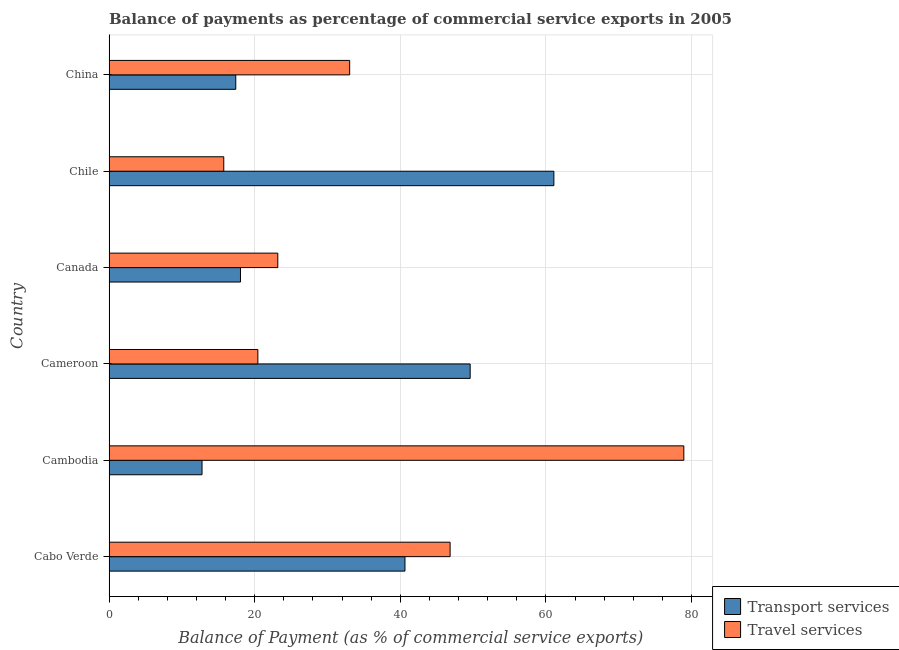How many groups of bars are there?
Ensure brevity in your answer.  6. Are the number of bars per tick equal to the number of legend labels?
Your answer should be compact. Yes. What is the label of the 4th group of bars from the top?
Keep it short and to the point. Cameroon. In how many cases, is the number of bars for a given country not equal to the number of legend labels?
Your answer should be compact. 0. What is the balance of payments of travel services in Cabo Verde?
Your answer should be compact. 46.84. Across all countries, what is the maximum balance of payments of travel services?
Offer a terse response. 78.94. Across all countries, what is the minimum balance of payments of travel services?
Provide a short and direct response. 15.75. In which country was the balance of payments of travel services maximum?
Make the answer very short. Cambodia. What is the total balance of payments of travel services in the graph?
Provide a short and direct response. 218.18. What is the difference between the balance of payments of travel services in Cabo Verde and that in Chile?
Your answer should be compact. 31.09. What is the difference between the balance of payments of travel services in Cambodia and the balance of payments of transport services in Cabo Verde?
Give a very brief answer. 38.3. What is the average balance of payments of transport services per country?
Give a very brief answer. 33.26. What is the difference between the balance of payments of travel services and balance of payments of transport services in Chile?
Offer a terse response. -45.34. In how many countries, is the balance of payments of travel services greater than 36 %?
Keep it short and to the point. 2. What is the ratio of the balance of payments of transport services in Cabo Verde to that in Cameroon?
Provide a short and direct response. 0.82. What is the difference between the highest and the second highest balance of payments of travel services?
Offer a terse response. 32.1. What is the difference between the highest and the lowest balance of payments of travel services?
Your answer should be compact. 63.19. In how many countries, is the balance of payments of travel services greater than the average balance of payments of travel services taken over all countries?
Provide a succinct answer. 2. What does the 1st bar from the top in Cabo Verde represents?
Offer a very short reply. Travel services. What does the 2nd bar from the bottom in China represents?
Provide a short and direct response. Travel services. How many bars are there?
Keep it short and to the point. 12. Are all the bars in the graph horizontal?
Give a very brief answer. Yes. Are the values on the major ticks of X-axis written in scientific E-notation?
Your response must be concise. No. Does the graph contain any zero values?
Ensure brevity in your answer.  No. Where does the legend appear in the graph?
Your answer should be very brief. Bottom right. How many legend labels are there?
Your response must be concise. 2. How are the legend labels stacked?
Provide a short and direct response. Vertical. What is the title of the graph?
Offer a terse response. Balance of payments as percentage of commercial service exports in 2005. Does "Not attending school" appear as one of the legend labels in the graph?
Your response must be concise. No. What is the label or title of the X-axis?
Keep it short and to the point. Balance of Payment (as % of commercial service exports). What is the label or title of the Y-axis?
Offer a very short reply. Country. What is the Balance of Payment (as % of commercial service exports) of Transport services in Cabo Verde?
Ensure brevity in your answer.  40.64. What is the Balance of Payment (as % of commercial service exports) in Travel services in Cabo Verde?
Your response must be concise. 46.84. What is the Balance of Payment (as % of commercial service exports) of Transport services in Cambodia?
Offer a very short reply. 12.77. What is the Balance of Payment (as % of commercial service exports) of Travel services in Cambodia?
Keep it short and to the point. 78.94. What is the Balance of Payment (as % of commercial service exports) of Transport services in Cameroon?
Give a very brief answer. 49.59. What is the Balance of Payment (as % of commercial service exports) of Travel services in Cameroon?
Ensure brevity in your answer.  20.43. What is the Balance of Payment (as % of commercial service exports) of Transport services in Canada?
Offer a very short reply. 18.05. What is the Balance of Payment (as % of commercial service exports) in Travel services in Canada?
Provide a succinct answer. 23.17. What is the Balance of Payment (as % of commercial service exports) of Transport services in Chile?
Keep it short and to the point. 61.09. What is the Balance of Payment (as % of commercial service exports) of Travel services in Chile?
Offer a terse response. 15.75. What is the Balance of Payment (as % of commercial service exports) in Transport services in China?
Offer a terse response. 17.4. What is the Balance of Payment (as % of commercial service exports) of Travel services in China?
Your response must be concise. 33.04. Across all countries, what is the maximum Balance of Payment (as % of commercial service exports) of Transport services?
Give a very brief answer. 61.09. Across all countries, what is the maximum Balance of Payment (as % of commercial service exports) of Travel services?
Give a very brief answer. 78.94. Across all countries, what is the minimum Balance of Payment (as % of commercial service exports) of Transport services?
Provide a succinct answer. 12.77. Across all countries, what is the minimum Balance of Payment (as % of commercial service exports) of Travel services?
Give a very brief answer. 15.75. What is the total Balance of Payment (as % of commercial service exports) of Transport services in the graph?
Provide a short and direct response. 199.54. What is the total Balance of Payment (as % of commercial service exports) in Travel services in the graph?
Offer a terse response. 218.18. What is the difference between the Balance of Payment (as % of commercial service exports) in Transport services in Cabo Verde and that in Cambodia?
Your answer should be compact. 27.87. What is the difference between the Balance of Payment (as % of commercial service exports) of Travel services in Cabo Verde and that in Cambodia?
Give a very brief answer. -32.1. What is the difference between the Balance of Payment (as % of commercial service exports) in Transport services in Cabo Verde and that in Cameroon?
Ensure brevity in your answer.  -8.95. What is the difference between the Balance of Payment (as % of commercial service exports) of Travel services in Cabo Verde and that in Cameroon?
Offer a very short reply. 26.4. What is the difference between the Balance of Payment (as % of commercial service exports) in Transport services in Cabo Verde and that in Canada?
Ensure brevity in your answer.  22.59. What is the difference between the Balance of Payment (as % of commercial service exports) of Travel services in Cabo Verde and that in Canada?
Keep it short and to the point. 23.66. What is the difference between the Balance of Payment (as % of commercial service exports) of Transport services in Cabo Verde and that in Chile?
Keep it short and to the point. -20.45. What is the difference between the Balance of Payment (as % of commercial service exports) in Travel services in Cabo Verde and that in Chile?
Make the answer very short. 31.08. What is the difference between the Balance of Payment (as % of commercial service exports) of Transport services in Cabo Verde and that in China?
Make the answer very short. 23.24. What is the difference between the Balance of Payment (as % of commercial service exports) of Travel services in Cabo Verde and that in China?
Make the answer very short. 13.79. What is the difference between the Balance of Payment (as % of commercial service exports) of Transport services in Cambodia and that in Cameroon?
Your answer should be compact. -36.83. What is the difference between the Balance of Payment (as % of commercial service exports) in Travel services in Cambodia and that in Cameroon?
Provide a short and direct response. 58.5. What is the difference between the Balance of Payment (as % of commercial service exports) of Transport services in Cambodia and that in Canada?
Ensure brevity in your answer.  -5.28. What is the difference between the Balance of Payment (as % of commercial service exports) of Travel services in Cambodia and that in Canada?
Make the answer very short. 55.76. What is the difference between the Balance of Payment (as % of commercial service exports) in Transport services in Cambodia and that in Chile?
Provide a short and direct response. -48.32. What is the difference between the Balance of Payment (as % of commercial service exports) in Travel services in Cambodia and that in Chile?
Your response must be concise. 63.19. What is the difference between the Balance of Payment (as % of commercial service exports) of Transport services in Cambodia and that in China?
Give a very brief answer. -4.63. What is the difference between the Balance of Payment (as % of commercial service exports) in Travel services in Cambodia and that in China?
Your answer should be very brief. 45.89. What is the difference between the Balance of Payment (as % of commercial service exports) of Transport services in Cameroon and that in Canada?
Your response must be concise. 31.55. What is the difference between the Balance of Payment (as % of commercial service exports) of Travel services in Cameroon and that in Canada?
Give a very brief answer. -2.74. What is the difference between the Balance of Payment (as % of commercial service exports) in Transport services in Cameroon and that in Chile?
Give a very brief answer. -11.5. What is the difference between the Balance of Payment (as % of commercial service exports) of Travel services in Cameroon and that in Chile?
Offer a terse response. 4.68. What is the difference between the Balance of Payment (as % of commercial service exports) in Transport services in Cameroon and that in China?
Offer a terse response. 32.19. What is the difference between the Balance of Payment (as % of commercial service exports) in Travel services in Cameroon and that in China?
Ensure brevity in your answer.  -12.61. What is the difference between the Balance of Payment (as % of commercial service exports) of Transport services in Canada and that in Chile?
Your answer should be very brief. -43.04. What is the difference between the Balance of Payment (as % of commercial service exports) in Travel services in Canada and that in Chile?
Offer a very short reply. 7.42. What is the difference between the Balance of Payment (as % of commercial service exports) of Transport services in Canada and that in China?
Make the answer very short. 0.65. What is the difference between the Balance of Payment (as % of commercial service exports) of Travel services in Canada and that in China?
Provide a short and direct response. -9.87. What is the difference between the Balance of Payment (as % of commercial service exports) of Transport services in Chile and that in China?
Your response must be concise. 43.69. What is the difference between the Balance of Payment (as % of commercial service exports) of Travel services in Chile and that in China?
Your answer should be very brief. -17.29. What is the difference between the Balance of Payment (as % of commercial service exports) in Transport services in Cabo Verde and the Balance of Payment (as % of commercial service exports) in Travel services in Cambodia?
Provide a short and direct response. -38.3. What is the difference between the Balance of Payment (as % of commercial service exports) of Transport services in Cabo Verde and the Balance of Payment (as % of commercial service exports) of Travel services in Cameroon?
Keep it short and to the point. 20.21. What is the difference between the Balance of Payment (as % of commercial service exports) of Transport services in Cabo Verde and the Balance of Payment (as % of commercial service exports) of Travel services in Canada?
Make the answer very short. 17.47. What is the difference between the Balance of Payment (as % of commercial service exports) of Transport services in Cabo Verde and the Balance of Payment (as % of commercial service exports) of Travel services in Chile?
Provide a succinct answer. 24.89. What is the difference between the Balance of Payment (as % of commercial service exports) of Transport services in Cabo Verde and the Balance of Payment (as % of commercial service exports) of Travel services in China?
Your answer should be very brief. 7.59. What is the difference between the Balance of Payment (as % of commercial service exports) of Transport services in Cambodia and the Balance of Payment (as % of commercial service exports) of Travel services in Cameroon?
Offer a very short reply. -7.67. What is the difference between the Balance of Payment (as % of commercial service exports) in Transport services in Cambodia and the Balance of Payment (as % of commercial service exports) in Travel services in Canada?
Your answer should be compact. -10.41. What is the difference between the Balance of Payment (as % of commercial service exports) of Transport services in Cambodia and the Balance of Payment (as % of commercial service exports) of Travel services in Chile?
Provide a short and direct response. -2.99. What is the difference between the Balance of Payment (as % of commercial service exports) in Transport services in Cambodia and the Balance of Payment (as % of commercial service exports) in Travel services in China?
Offer a terse response. -20.28. What is the difference between the Balance of Payment (as % of commercial service exports) of Transport services in Cameroon and the Balance of Payment (as % of commercial service exports) of Travel services in Canada?
Your answer should be very brief. 26.42. What is the difference between the Balance of Payment (as % of commercial service exports) in Transport services in Cameroon and the Balance of Payment (as % of commercial service exports) in Travel services in Chile?
Make the answer very short. 33.84. What is the difference between the Balance of Payment (as % of commercial service exports) of Transport services in Cameroon and the Balance of Payment (as % of commercial service exports) of Travel services in China?
Your answer should be compact. 16.55. What is the difference between the Balance of Payment (as % of commercial service exports) in Transport services in Canada and the Balance of Payment (as % of commercial service exports) in Travel services in Chile?
Provide a short and direct response. 2.3. What is the difference between the Balance of Payment (as % of commercial service exports) of Transport services in Canada and the Balance of Payment (as % of commercial service exports) of Travel services in China?
Your answer should be compact. -15. What is the difference between the Balance of Payment (as % of commercial service exports) in Transport services in Chile and the Balance of Payment (as % of commercial service exports) in Travel services in China?
Your answer should be compact. 28.05. What is the average Balance of Payment (as % of commercial service exports) in Transport services per country?
Your answer should be very brief. 33.26. What is the average Balance of Payment (as % of commercial service exports) in Travel services per country?
Provide a succinct answer. 36.36. What is the difference between the Balance of Payment (as % of commercial service exports) of Transport services and Balance of Payment (as % of commercial service exports) of Travel services in Cabo Verde?
Provide a short and direct response. -6.2. What is the difference between the Balance of Payment (as % of commercial service exports) in Transport services and Balance of Payment (as % of commercial service exports) in Travel services in Cambodia?
Offer a terse response. -66.17. What is the difference between the Balance of Payment (as % of commercial service exports) of Transport services and Balance of Payment (as % of commercial service exports) of Travel services in Cameroon?
Provide a succinct answer. 29.16. What is the difference between the Balance of Payment (as % of commercial service exports) in Transport services and Balance of Payment (as % of commercial service exports) in Travel services in Canada?
Provide a short and direct response. -5.12. What is the difference between the Balance of Payment (as % of commercial service exports) of Transport services and Balance of Payment (as % of commercial service exports) of Travel services in Chile?
Offer a terse response. 45.34. What is the difference between the Balance of Payment (as % of commercial service exports) of Transport services and Balance of Payment (as % of commercial service exports) of Travel services in China?
Keep it short and to the point. -15.64. What is the ratio of the Balance of Payment (as % of commercial service exports) in Transport services in Cabo Verde to that in Cambodia?
Your answer should be very brief. 3.18. What is the ratio of the Balance of Payment (as % of commercial service exports) of Travel services in Cabo Verde to that in Cambodia?
Offer a terse response. 0.59. What is the ratio of the Balance of Payment (as % of commercial service exports) of Transport services in Cabo Verde to that in Cameroon?
Keep it short and to the point. 0.82. What is the ratio of the Balance of Payment (as % of commercial service exports) in Travel services in Cabo Verde to that in Cameroon?
Your response must be concise. 2.29. What is the ratio of the Balance of Payment (as % of commercial service exports) in Transport services in Cabo Verde to that in Canada?
Your answer should be compact. 2.25. What is the ratio of the Balance of Payment (as % of commercial service exports) in Travel services in Cabo Verde to that in Canada?
Provide a short and direct response. 2.02. What is the ratio of the Balance of Payment (as % of commercial service exports) of Transport services in Cabo Verde to that in Chile?
Keep it short and to the point. 0.67. What is the ratio of the Balance of Payment (as % of commercial service exports) in Travel services in Cabo Verde to that in Chile?
Offer a terse response. 2.97. What is the ratio of the Balance of Payment (as % of commercial service exports) of Transport services in Cabo Verde to that in China?
Keep it short and to the point. 2.34. What is the ratio of the Balance of Payment (as % of commercial service exports) in Travel services in Cabo Verde to that in China?
Ensure brevity in your answer.  1.42. What is the ratio of the Balance of Payment (as % of commercial service exports) of Transport services in Cambodia to that in Cameroon?
Give a very brief answer. 0.26. What is the ratio of the Balance of Payment (as % of commercial service exports) of Travel services in Cambodia to that in Cameroon?
Provide a succinct answer. 3.86. What is the ratio of the Balance of Payment (as % of commercial service exports) of Transport services in Cambodia to that in Canada?
Your answer should be compact. 0.71. What is the ratio of the Balance of Payment (as % of commercial service exports) of Travel services in Cambodia to that in Canada?
Keep it short and to the point. 3.41. What is the ratio of the Balance of Payment (as % of commercial service exports) in Transport services in Cambodia to that in Chile?
Ensure brevity in your answer.  0.21. What is the ratio of the Balance of Payment (as % of commercial service exports) in Travel services in Cambodia to that in Chile?
Make the answer very short. 5.01. What is the ratio of the Balance of Payment (as % of commercial service exports) of Transport services in Cambodia to that in China?
Your response must be concise. 0.73. What is the ratio of the Balance of Payment (as % of commercial service exports) in Travel services in Cambodia to that in China?
Your answer should be very brief. 2.39. What is the ratio of the Balance of Payment (as % of commercial service exports) in Transport services in Cameroon to that in Canada?
Keep it short and to the point. 2.75. What is the ratio of the Balance of Payment (as % of commercial service exports) of Travel services in Cameroon to that in Canada?
Your answer should be compact. 0.88. What is the ratio of the Balance of Payment (as % of commercial service exports) of Transport services in Cameroon to that in Chile?
Give a very brief answer. 0.81. What is the ratio of the Balance of Payment (as % of commercial service exports) in Travel services in Cameroon to that in Chile?
Provide a succinct answer. 1.3. What is the ratio of the Balance of Payment (as % of commercial service exports) of Transport services in Cameroon to that in China?
Keep it short and to the point. 2.85. What is the ratio of the Balance of Payment (as % of commercial service exports) in Travel services in Cameroon to that in China?
Give a very brief answer. 0.62. What is the ratio of the Balance of Payment (as % of commercial service exports) of Transport services in Canada to that in Chile?
Provide a short and direct response. 0.3. What is the ratio of the Balance of Payment (as % of commercial service exports) of Travel services in Canada to that in Chile?
Your response must be concise. 1.47. What is the ratio of the Balance of Payment (as % of commercial service exports) in Transport services in Canada to that in China?
Ensure brevity in your answer.  1.04. What is the ratio of the Balance of Payment (as % of commercial service exports) in Travel services in Canada to that in China?
Your response must be concise. 0.7. What is the ratio of the Balance of Payment (as % of commercial service exports) in Transport services in Chile to that in China?
Provide a short and direct response. 3.51. What is the ratio of the Balance of Payment (as % of commercial service exports) of Travel services in Chile to that in China?
Offer a very short reply. 0.48. What is the difference between the highest and the second highest Balance of Payment (as % of commercial service exports) of Transport services?
Your answer should be very brief. 11.5. What is the difference between the highest and the second highest Balance of Payment (as % of commercial service exports) of Travel services?
Make the answer very short. 32.1. What is the difference between the highest and the lowest Balance of Payment (as % of commercial service exports) of Transport services?
Give a very brief answer. 48.32. What is the difference between the highest and the lowest Balance of Payment (as % of commercial service exports) in Travel services?
Offer a very short reply. 63.19. 